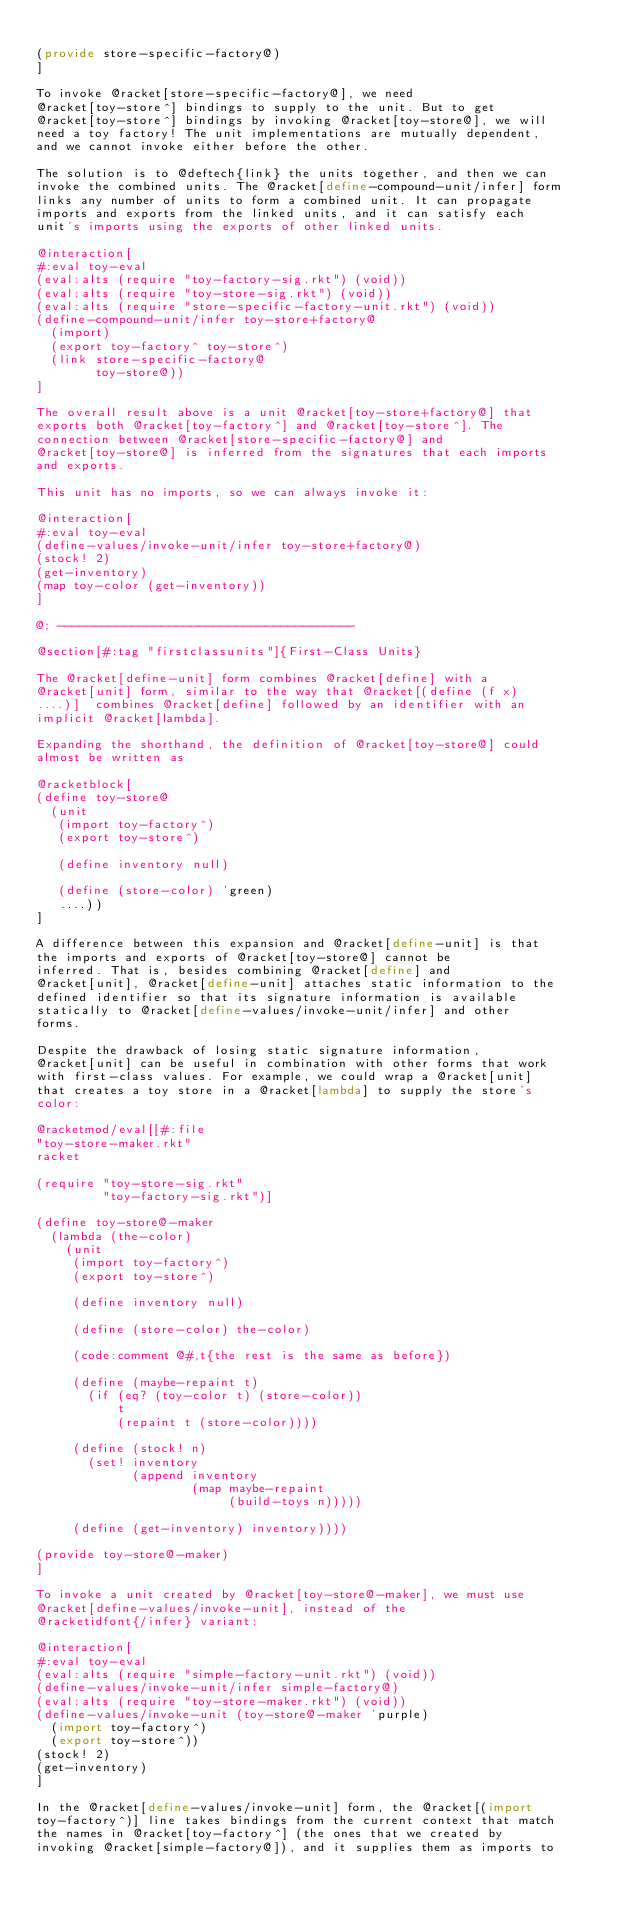Convert code to text. <code><loc_0><loc_0><loc_500><loc_500><_Racket_>
(provide store-specific-factory@)
]

To invoke @racket[store-specific-factory@], we need
@racket[toy-store^] bindings to supply to the unit. But to get
@racket[toy-store^] bindings by invoking @racket[toy-store@], we will
need a toy factory! The unit implementations are mutually dependent,
and we cannot invoke either before the other.

The solution is to @deftech{link} the units together, and then we can
invoke the combined units. The @racket[define-compound-unit/infer] form
links any number of units to form a combined unit. It can propagate
imports and exports from the linked units, and it can satisfy each
unit's imports using the exports of other linked units.

@interaction[
#:eval toy-eval
(eval:alts (require "toy-factory-sig.rkt") (void))
(eval:alts (require "toy-store-sig.rkt") (void))
(eval:alts (require "store-specific-factory-unit.rkt") (void))
(define-compound-unit/infer toy-store+factory@
  (import)
  (export toy-factory^ toy-store^)
  (link store-specific-factory@
        toy-store@))
]

The overall result above is a unit @racket[toy-store+factory@] that
exports both @racket[toy-factory^] and @racket[toy-store^]. The
connection between @racket[store-specific-factory@] and
@racket[toy-store@] is inferred from the signatures that each imports
and exports.

This unit has no imports, so we can always invoke it:

@interaction[
#:eval toy-eval
(define-values/invoke-unit/infer toy-store+factory@)
(stock! 2)
(get-inventory)
(map toy-color (get-inventory))
]

@; ----------------------------------------

@section[#:tag "firstclassunits"]{First-Class Units}

The @racket[define-unit] form combines @racket[define] with a
@racket[unit] form, similar to the way that @racket[(define (f x)
....)]  combines @racket[define] followed by an identifier with an
implicit @racket[lambda].

Expanding the shorthand, the definition of @racket[toy-store@] could
almost be written as

@racketblock[
(define toy-store@
  (unit
   (import toy-factory^)
   (export toy-store^)

   (define inventory null)

   (define (store-color) 'green)
   ....))
]

A difference between this expansion and @racket[define-unit] is that
the imports and exports of @racket[toy-store@] cannot be
inferred. That is, besides combining @racket[define] and
@racket[unit], @racket[define-unit] attaches static information to the
defined identifier so that its signature information is available
statically to @racket[define-values/invoke-unit/infer] and other
forms.

Despite the drawback of losing static signature information,
@racket[unit] can be useful in combination with other forms that work
with first-class values. For example, we could wrap a @racket[unit]
that creates a toy store in a @racket[lambda] to supply the store's
color:

@racketmod/eval[[#:file
"toy-store-maker.rkt"
racket

(require "toy-store-sig.rkt"
         "toy-factory-sig.rkt")]

(define toy-store@-maker
  (lambda (the-color)
    (unit
     (import toy-factory^)
     (export toy-store^)

     (define inventory null)

     (define (store-color) the-color)

     (code:comment @#,t{the rest is the same as before})

     (define (maybe-repaint t)
       (if (eq? (toy-color t) (store-color))
           t
           (repaint t (store-color))))

     (define (stock! n)
       (set! inventory
             (append inventory
                     (map maybe-repaint
                          (build-toys n)))))

     (define (get-inventory) inventory))))

(provide toy-store@-maker)
]

To invoke a unit created by @racket[toy-store@-maker], we must use
@racket[define-values/invoke-unit], instead of the
@racketidfont{/infer} variant:

@interaction[
#:eval toy-eval
(eval:alts (require "simple-factory-unit.rkt") (void))
(define-values/invoke-unit/infer simple-factory@)
(eval:alts (require "toy-store-maker.rkt") (void))
(define-values/invoke-unit (toy-store@-maker 'purple)
  (import toy-factory^)
  (export toy-store^))
(stock! 2)
(get-inventory)
]

In the @racket[define-values/invoke-unit] form, the @racket[(import
toy-factory^)] line takes bindings from the current context that match
the names in @racket[toy-factory^] (the ones that we created by
invoking @racket[simple-factory@]), and it supplies them as imports to</code> 